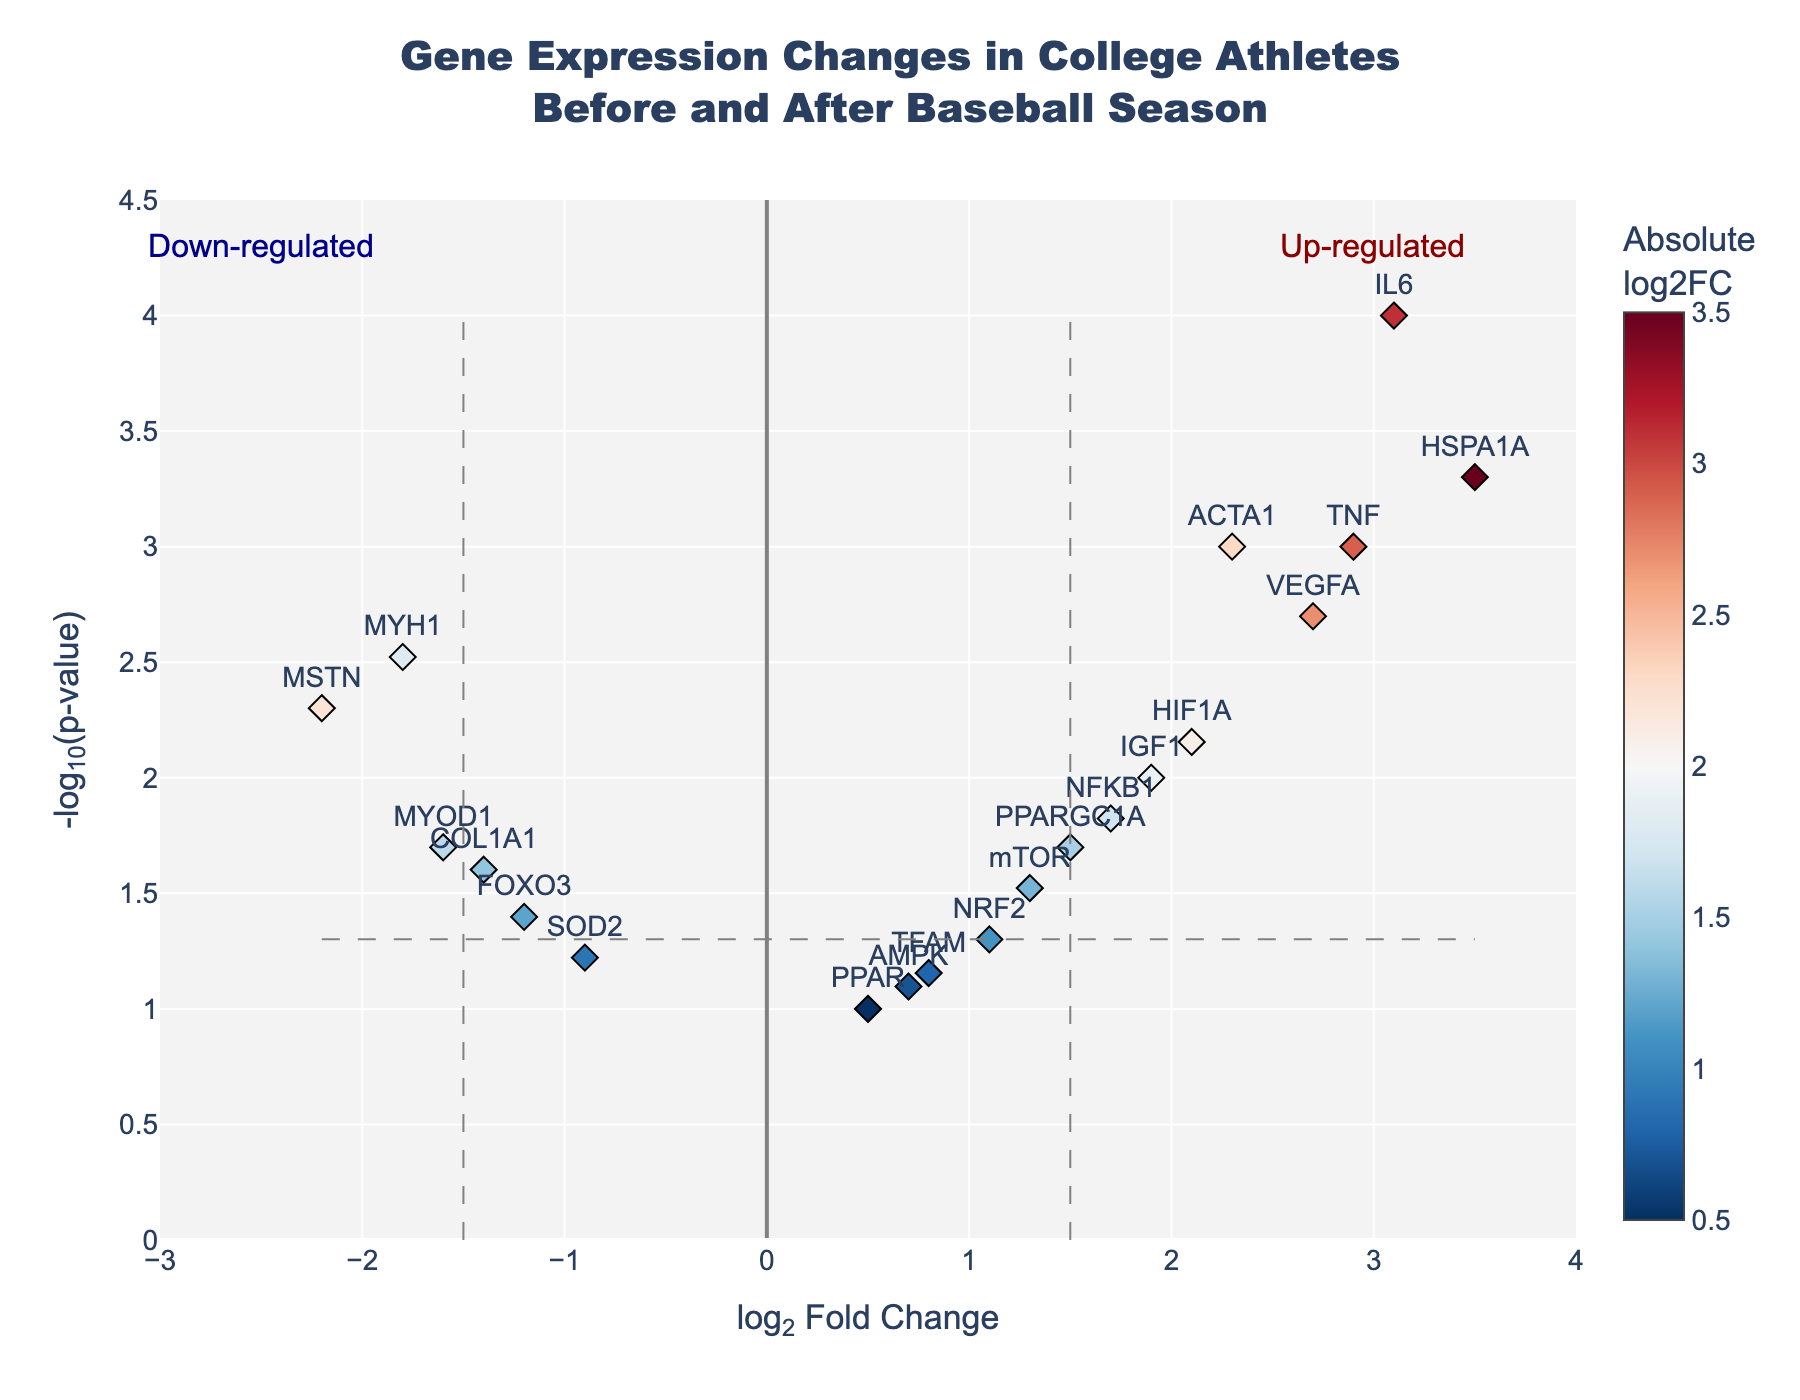what is the title of the plot? The title of the plot is located at the top and is typically the largest text on the figure. It describes what the plot is about.
Answer: "Gene Expression Changes in College Athletes Before and After Baseball Season" how many genes are shown in the plot? Each gene is represented by a diamond on the plot with a label. Count the number of labels present.
Answer: 20 what does the x-axis represent? The x-axis label is typically located below the axis and describes what the horizontal position indicates.
Answer: log2 Fold Change what does the y-axis represent? The y-axis label is usually located to the left of the axis and describes what the vertical position indicates.
Answer: -log10(p-value) which gene has the highest log2 fold change? Identify the data point that is farthest to the right on the x-axis and refer to its label.
Answer: HSPA1A what’s the -log10(p-value) of the gene IL6? Find the IL6 label on the plot and read its vertical position on the y-axis.
Answer: 4 how many genes have a log2 fold change greater than 1.5? Identify all data points (genes) that are to the right of the 1.5 line on the x-axis.
Answer: 8 which gene is more down-regulated, MYH1 or FOXO3? Locate MYH1 and FOXO3 on the plot and compare their positions on the left side of the x-axis. A more down-regulated gene will have a more negative log2 fold change.
Answer: MYH1 are there any genes with a -log10(p-value) less than 1? Look at the y-axis and see if there are any points below the value of 1.
Answer: No which genes are considered significantly up-regulated? Genes above the horizontal line at -log10(p-value) of 1.3 and to the right of the vertical line at log2 fold change of 1.5 are considered significantly up-regulated.
Answer: IL6, HSPA1A, TNF which gene is closer to the threshold for being considered significantly down-regulated based on p-value? Genes below the horizontal threshold (-log10(p-value) of 1.3) and left of the vertical threshold (log2 fold change of -1.5) are candidates. Compare these genes to find the closest one to the threshold.
Answer: FOXO3 